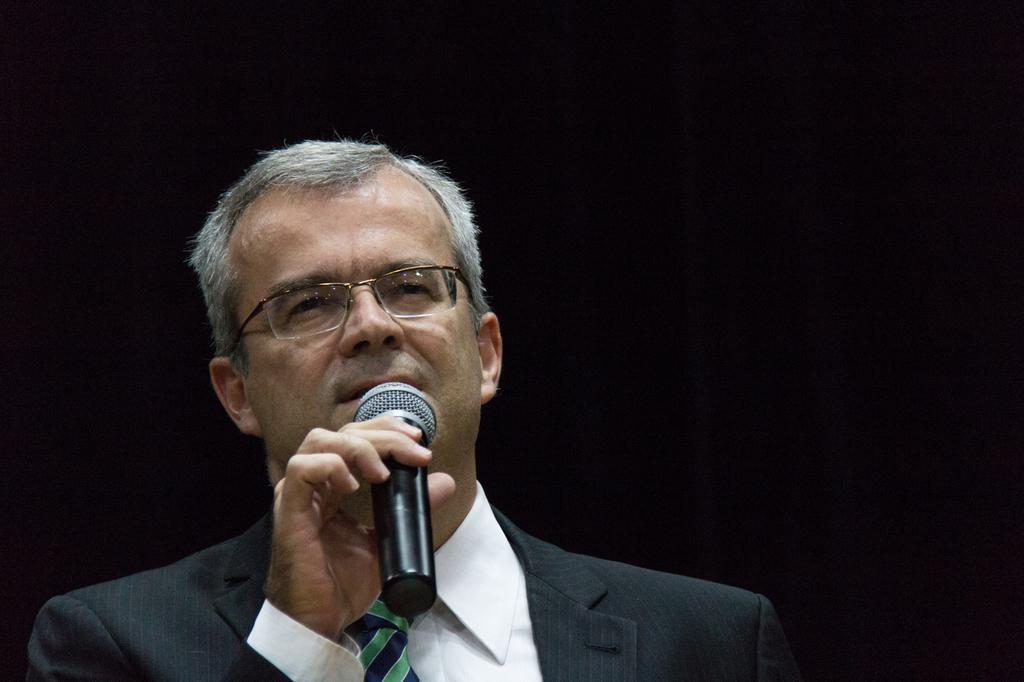Who is the main subject in the image? There is a man in the image. What is the man wearing? The man is wearing spectacles. What is the man holding in his hands? The man is holding a mic in his hands. What is the man doing in the image? The man is talking. What can be observed about the background of the image? The background of the image is dark. How many songs can be heard playing in the background of the image? There is no indication of any songs playing in the background of the image. What type of bridge is visible in the image? There is no bridge present in the image. 